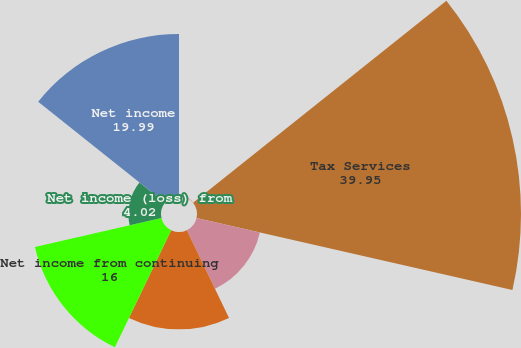Convert chart to OTSL. <chart><loc_0><loc_0><loc_500><loc_500><pie_chart><fcel>Year ended April 30<fcel>Tax Services<fcel>Corporate and eliminations<fcel>Income taxes<fcel>Net income from continuing<fcel>Net income (loss) from<fcel>Net income<nl><fcel>0.03%<fcel>39.95%<fcel>8.01%<fcel>12.0%<fcel>16.0%<fcel>4.02%<fcel>19.99%<nl></chart> 